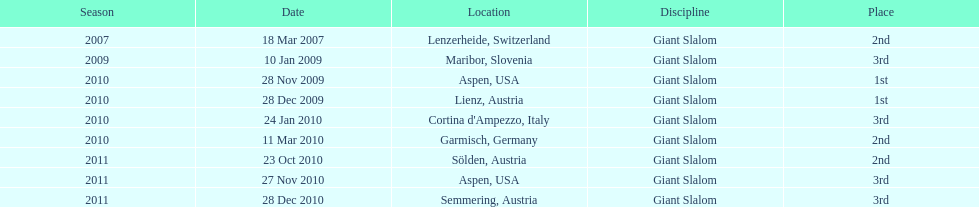How many races were in 2010? 5. 